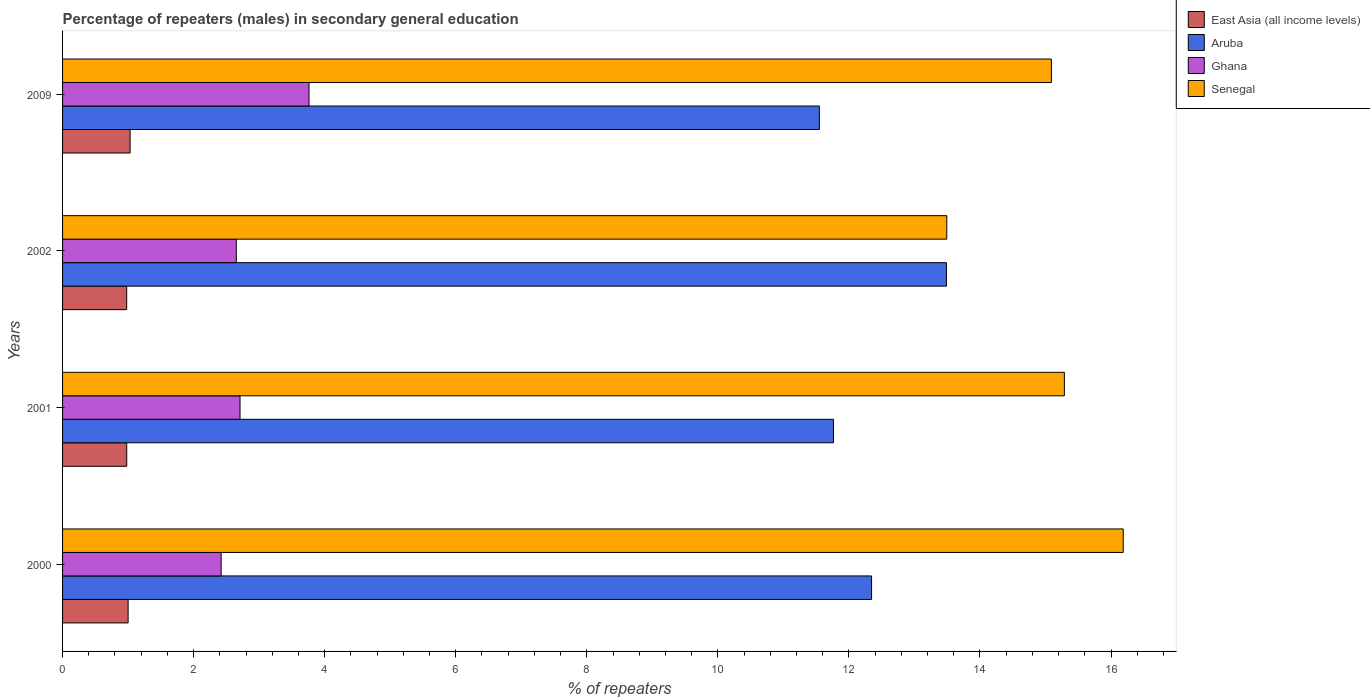How many different coloured bars are there?
Keep it short and to the point. 4. How many bars are there on the 2nd tick from the top?
Your answer should be very brief. 4. How many bars are there on the 1st tick from the bottom?
Your answer should be very brief. 4. What is the label of the 3rd group of bars from the top?
Offer a very short reply. 2001. In how many cases, is the number of bars for a given year not equal to the number of legend labels?
Offer a terse response. 0. What is the percentage of male repeaters in Senegal in 2000?
Keep it short and to the point. 16.19. Across all years, what is the maximum percentage of male repeaters in East Asia (all income levels)?
Your answer should be compact. 1.03. Across all years, what is the minimum percentage of male repeaters in Aruba?
Provide a succinct answer. 11.55. In which year was the percentage of male repeaters in East Asia (all income levels) maximum?
Offer a terse response. 2009. What is the total percentage of male repeaters in Ghana in the graph?
Ensure brevity in your answer.  11.54. What is the difference between the percentage of male repeaters in East Asia (all income levels) in 2001 and that in 2009?
Make the answer very short. -0.05. What is the difference between the percentage of male repeaters in Ghana in 2009 and the percentage of male repeaters in Senegal in 2000?
Make the answer very short. -12.43. What is the average percentage of male repeaters in Aruba per year?
Offer a very short reply. 12.29. In the year 2000, what is the difference between the percentage of male repeaters in East Asia (all income levels) and percentage of male repeaters in Aruba?
Your answer should be very brief. -11.35. In how many years, is the percentage of male repeaters in Senegal greater than 2.8 %?
Offer a terse response. 4. What is the ratio of the percentage of male repeaters in Ghana in 2001 to that in 2002?
Give a very brief answer. 1.02. Is the percentage of male repeaters in Aruba in 2001 less than that in 2002?
Provide a succinct answer. Yes. Is the difference between the percentage of male repeaters in East Asia (all income levels) in 2001 and 2009 greater than the difference between the percentage of male repeaters in Aruba in 2001 and 2009?
Your response must be concise. No. What is the difference between the highest and the second highest percentage of male repeaters in East Asia (all income levels)?
Give a very brief answer. 0.03. What is the difference between the highest and the lowest percentage of male repeaters in Aruba?
Provide a short and direct response. 1.94. Is it the case that in every year, the sum of the percentage of male repeaters in Aruba and percentage of male repeaters in East Asia (all income levels) is greater than the sum of percentage of male repeaters in Senegal and percentage of male repeaters in Ghana?
Provide a short and direct response. No. What does the 3rd bar from the top in 2000 represents?
Offer a very short reply. Aruba. What does the 3rd bar from the bottom in 2009 represents?
Keep it short and to the point. Ghana. How many years are there in the graph?
Keep it short and to the point. 4. Are the values on the major ticks of X-axis written in scientific E-notation?
Keep it short and to the point. No. Does the graph contain grids?
Offer a very short reply. No. How many legend labels are there?
Provide a succinct answer. 4. How are the legend labels stacked?
Provide a succinct answer. Vertical. What is the title of the graph?
Your answer should be compact. Percentage of repeaters (males) in secondary general education. What is the label or title of the X-axis?
Offer a terse response. % of repeaters. What is the label or title of the Y-axis?
Keep it short and to the point. Years. What is the % of repeaters of East Asia (all income levels) in 2000?
Ensure brevity in your answer.  1. What is the % of repeaters of Aruba in 2000?
Provide a short and direct response. 12.35. What is the % of repeaters in Ghana in 2000?
Provide a short and direct response. 2.42. What is the % of repeaters of Senegal in 2000?
Your response must be concise. 16.19. What is the % of repeaters in East Asia (all income levels) in 2001?
Provide a succinct answer. 0.98. What is the % of repeaters in Aruba in 2001?
Keep it short and to the point. 11.76. What is the % of repeaters of Ghana in 2001?
Provide a short and direct response. 2.71. What is the % of repeaters of Senegal in 2001?
Ensure brevity in your answer.  15.29. What is the % of repeaters in East Asia (all income levels) in 2002?
Your response must be concise. 0.98. What is the % of repeaters of Aruba in 2002?
Provide a short and direct response. 13.49. What is the % of repeaters of Ghana in 2002?
Provide a succinct answer. 2.65. What is the % of repeaters in Senegal in 2002?
Keep it short and to the point. 13.49. What is the % of repeaters of East Asia (all income levels) in 2009?
Keep it short and to the point. 1.03. What is the % of repeaters of Aruba in 2009?
Provide a succinct answer. 11.55. What is the % of repeaters of Ghana in 2009?
Offer a terse response. 3.76. What is the % of repeaters in Senegal in 2009?
Provide a short and direct response. 15.09. Across all years, what is the maximum % of repeaters of East Asia (all income levels)?
Your response must be concise. 1.03. Across all years, what is the maximum % of repeaters of Aruba?
Your answer should be compact. 13.49. Across all years, what is the maximum % of repeaters of Ghana?
Offer a very short reply. 3.76. Across all years, what is the maximum % of repeaters of Senegal?
Provide a succinct answer. 16.19. Across all years, what is the minimum % of repeaters in East Asia (all income levels)?
Provide a succinct answer. 0.98. Across all years, what is the minimum % of repeaters in Aruba?
Offer a terse response. 11.55. Across all years, what is the minimum % of repeaters in Ghana?
Keep it short and to the point. 2.42. Across all years, what is the minimum % of repeaters of Senegal?
Provide a succinct answer. 13.49. What is the total % of repeaters of East Asia (all income levels) in the graph?
Offer a terse response. 3.99. What is the total % of repeaters in Aruba in the graph?
Your response must be concise. 49.15. What is the total % of repeaters in Ghana in the graph?
Keep it short and to the point. 11.54. What is the total % of repeaters of Senegal in the graph?
Offer a terse response. 60.06. What is the difference between the % of repeaters of East Asia (all income levels) in 2000 and that in 2001?
Make the answer very short. 0.02. What is the difference between the % of repeaters in Aruba in 2000 and that in 2001?
Give a very brief answer. 0.58. What is the difference between the % of repeaters in Ghana in 2000 and that in 2001?
Your answer should be very brief. -0.29. What is the difference between the % of repeaters of Senegal in 2000 and that in 2001?
Your answer should be very brief. 0.9. What is the difference between the % of repeaters of East Asia (all income levels) in 2000 and that in 2002?
Your answer should be compact. 0.02. What is the difference between the % of repeaters in Aruba in 2000 and that in 2002?
Offer a very short reply. -1.14. What is the difference between the % of repeaters of Ghana in 2000 and that in 2002?
Provide a succinct answer. -0.23. What is the difference between the % of repeaters in Senegal in 2000 and that in 2002?
Provide a succinct answer. 2.69. What is the difference between the % of repeaters in East Asia (all income levels) in 2000 and that in 2009?
Provide a short and direct response. -0.03. What is the difference between the % of repeaters of Aruba in 2000 and that in 2009?
Your answer should be very brief. 0.8. What is the difference between the % of repeaters of Ghana in 2000 and that in 2009?
Your response must be concise. -1.34. What is the difference between the % of repeaters of Senegal in 2000 and that in 2009?
Give a very brief answer. 1.1. What is the difference between the % of repeaters of East Asia (all income levels) in 2001 and that in 2002?
Your response must be concise. 0. What is the difference between the % of repeaters of Aruba in 2001 and that in 2002?
Make the answer very short. -1.72. What is the difference between the % of repeaters in Ghana in 2001 and that in 2002?
Offer a terse response. 0.06. What is the difference between the % of repeaters in Senegal in 2001 and that in 2002?
Ensure brevity in your answer.  1.79. What is the difference between the % of repeaters in East Asia (all income levels) in 2001 and that in 2009?
Make the answer very short. -0.05. What is the difference between the % of repeaters in Aruba in 2001 and that in 2009?
Your answer should be very brief. 0.22. What is the difference between the % of repeaters in Ghana in 2001 and that in 2009?
Make the answer very short. -1.05. What is the difference between the % of repeaters in Senegal in 2001 and that in 2009?
Ensure brevity in your answer.  0.2. What is the difference between the % of repeaters of East Asia (all income levels) in 2002 and that in 2009?
Provide a succinct answer. -0.05. What is the difference between the % of repeaters in Aruba in 2002 and that in 2009?
Offer a very short reply. 1.94. What is the difference between the % of repeaters in Ghana in 2002 and that in 2009?
Your answer should be very brief. -1.11. What is the difference between the % of repeaters in Senegal in 2002 and that in 2009?
Your answer should be compact. -1.6. What is the difference between the % of repeaters in East Asia (all income levels) in 2000 and the % of repeaters in Aruba in 2001?
Your response must be concise. -10.76. What is the difference between the % of repeaters in East Asia (all income levels) in 2000 and the % of repeaters in Ghana in 2001?
Give a very brief answer. -1.71. What is the difference between the % of repeaters in East Asia (all income levels) in 2000 and the % of repeaters in Senegal in 2001?
Offer a terse response. -14.29. What is the difference between the % of repeaters in Aruba in 2000 and the % of repeaters in Ghana in 2001?
Your answer should be compact. 9.64. What is the difference between the % of repeaters in Aruba in 2000 and the % of repeaters in Senegal in 2001?
Offer a very short reply. -2.94. What is the difference between the % of repeaters in Ghana in 2000 and the % of repeaters in Senegal in 2001?
Make the answer very short. -12.87. What is the difference between the % of repeaters of East Asia (all income levels) in 2000 and the % of repeaters of Aruba in 2002?
Keep it short and to the point. -12.49. What is the difference between the % of repeaters of East Asia (all income levels) in 2000 and the % of repeaters of Ghana in 2002?
Provide a short and direct response. -1.65. What is the difference between the % of repeaters of East Asia (all income levels) in 2000 and the % of repeaters of Senegal in 2002?
Ensure brevity in your answer.  -12.49. What is the difference between the % of repeaters in Aruba in 2000 and the % of repeaters in Ghana in 2002?
Give a very brief answer. 9.69. What is the difference between the % of repeaters of Aruba in 2000 and the % of repeaters of Senegal in 2002?
Offer a terse response. -1.15. What is the difference between the % of repeaters of Ghana in 2000 and the % of repeaters of Senegal in 2002?
Offer a very short reply. -11.07. What is the difference between the % of repeaters of East Asia (all income levels) in 2000 and the % of repeaters of Aruba in 2009?
Offer a terse response. -10.55. What is the difference between the % of repeaters of East Asia (all income levels) in 2000 and the % of repeaters of Ghana in 2009?
Provide a short and direct response. -2.76. What is the difference between the % of repeaters of East Asia (all income levels) in 2000 and the % of repeaters of Senegal in 2009?
Your answer should be very brief. -14.09. What is the difference between the % of repeaters of Aruba in 2000 and the % of repeaters of Ghana in 2009?
Make the answer very short. 8.58. What is the difference between the % of repeaters of Aruba in 2000 and the % of repeaters of Senegal in 2009?
Keep it short and to the point. -2.74. What is the difference between the % of repeaters of Ghana in 2000 and the % of repeaters of Senegal in 2009?
Your answer should be compact. -12.67. What is the difference between the % of repeaters in East Asia (all income levels) in 2001 and the % of repeaters in Aruba in 2002?
Provide a short and direct response. -12.51. What is the difference between the % of repeaters of East Asia (all income levels) in 2001 and the % of repeaters of Ghana in 2002?
Keep it short and to the point. -1.67. What is the difference between the % of repeaters in East Asia (all income levels) in 2001 and the % of repeaters in Senegal in 2002?
Offer a terse response. -12.51. What is the difference between the % of repeaters of Aruba in 2001 and the % of repeaters of Ghana in 2002?
Your response must be concise. 9.11. What is the difference between the % of repeaters of Aruba in 2001 and the % of repeaters of Senegal in 2002?
Offer a very short reply. -1.73. What is the difference between the % of repeaters of Ghana in 2001 and the % of repeaters of Senegal in 2002?
Make the answer very short. -10.79. What is the difference between the % of repeaters of East Asia (all income levels) in 2001 and the % of repeaters of Aruba in 2009?
Keep it short and to the point. -10.57. What is the difference between the % of repeaters of East Asia (all income levels) in 2001 and the % of repeaters of Ghana in 2009?
Your answer should be very brief. -2.78. What is the difference between the % of repeaters in East Asia (all income levels) in 2001 and the % of repeaters in Senegal in 2009?
Ensure brevity in your answer.  -14.11. What is the difference between the % of repeaters of Aruba in 2001 and the % of repeaters of Ghana in 2009?
Give a very brief answer. 8. What is the difference between the % of repeaters in Aruba in 2001 and the % of repeaters in Senegal in 2009?
Give a very brief answer. -3.33. What is the difference between the % of repeaters in Ghana in 2001 and the % of repeaters in Senegal in 2009?
Your answer should be compact. -12.38. What is the difference between the % of repeaters of East Asia (all income levels) in 2002 and the % of repeaters of Aruba in 2009?
Ensure brevity in your answer.  -10.57. What is the difference between the % of repeaters in East Asia (all income levels) in 2002 and the % of repeaters in Ghana in 2009?
Ensure brevity in your answer.  -2.78. What is the difference between the % of repeaters of East Asia (all income levels) in 2002 and the % of repeaters of Senegal in 2009?
Make the answer very short. -14.11. What is the difference between the % of repeaters in Aruba in 2002 and the % of repeaters in Ghana in 2009?
Your answer should be very brief. 9.73. What is the difference between the % of repeaters of Aruba in 2002 and the % of repeaters of Senegal in 2009?
Your answer should be compact. -1.6. What is the difference between the % of repeaters in Ghana in 2002 and the % of repeaters in Senegal in 2009?
Your response must be concise. -12.44. What is the average % of repeaters in East Asia (all income levels) per year?
Give a very brief answer. 1. What is the average % of repeaters in Aruba per year?
Offer a terse response. 12.29. What is the average % of repeaters in Ghana per year?
Your response must be concise. 2.89. What is the average % of repeaters of Senegal per year?
Give a very brief answer. 15.01. In the year 2000, what is the difference between the % of repeaters in East Asia (all income levels) and % of repeaters in Aruba?
Ensure brevity in your answer.  -11.35. In the year 2000, what is the difference between the % of repeaters in East Asia (all income levels) and % of repeaters in Ghana?
Offer a terse response. -1.42. In the year 2000, what is the difference between the % of repeaters of East Asia (all income levels) and % of repeaters of Senegal?
Make the answer very short. -15.19. In the year 2000, what is the difference between the % of repeaters of Aruba and % of repeaters of Ghana?
Your answer should be compact. 9.93. In the year 2000, what is the difference between the % of repeaters in Aruba and % of repeaters in Senegal?
Provide a succinct answer. -3.84. In the year 2000, what is the difference between the % of repeaters in Ghana and % of repeaters in Senegal?
Provide a succinct answer. -13.77. In the year 2001, what is the difference between the % of repeaters in East Asia (all income levels) and % of repeaters in Aruba?
Make the answer very short. -10.79. In the year 2001, what is the difference between the % of repeaters in East Asia (all income levels) and % of repeaters in Ghana?
Give a very brief answer. -1.73. In the year 2001, what is the difference between the % of repeaters in East Asia (all income levels) and % of repeaters in Senegal?
Your answer should be compact. -14.31. In the year 2001, what is the difference between the % of repeaters of Aruba and % of repeaters of Ghana?
Provide a succinct answer. 9.06. In the year 2001, what is the difference between the % of repeaters of Aruba and % of repeaters of Senegal?
Provide a short and direct response. -3.52. In the year 2001, what is the difference between the % of repeaters of Ghana and % of repeaters of Senegal?
Provide a succinct answer. -12.58. In the year 2002, what is the difference between the % of repeaters in East Asia (all income levels) and % of repeaters in Aruba?
Provide a short and direct response. -12.51. In the year 2002, what is the difference between the % of repeaters in East Asia (all income levels) and % of repeaters in Ghana?
Give a very brief answer. -1.67. In the year 2002, what is the difference between the % of repeaters of East Asia (all income levels) and % of repeaters of Senegal?
Ensure brevity in your answer.  -12.52. In the year 2002, what is the difference between the % of repeaters of Aruba and % of repeaters of Ghana?
Provide a succinct answer. 10.84. In the year 2002, what is the difference between the % of repeaters in Aruba and % of repeaters in Senegal?
Provide a short and direct response. -0. In the year 2002, what is the difference between the % of repeaters in Ghana and % of repeaters in Senegal?
Ensure brevity in your answer.  -10.84. In the year 2009, what is the difference between the % of repeaters of East Asia (all income levels) and % of repeaters of Aruba?
Your response must be concise. -10.52. In the year 2009, what is the difference between the % of repeaters of East Asia (all income levels) and % of repeaters of Ghana?
Offer a very short reply. -2.73. In the year 2009, what is the difference between the % of repeaters of East Asia (all income levels) and % of repeaters of Senegal?
Your answer should be compact. -14.06. In the year 2009, what is the difference between the % of repeaters of Aruba and % of repeaters of Ghana?
Make the answer very short. 7.79. In the year 2009, what is the difference between the % of repeaters in Aruba and % of repeaters in Senegal?
Your answer should be compact. -3.54. In the year 2009, what is the difference between the % of repeaters in Ghana and % of repeaters in Senegal?
Make the answer very short. -11.33. What is the ratio of the % of repeaters in East Asia (all income levels) in 2000 to that in 2001?
Offer a very short reply. 1.02. What is the ratio of the % of repeaters of Aruba in 2000 to that in 2001?
Your answer should be compact. 1.05. What is the ratio of the % of repeaters in Ghana in 2000 to that in 2001?
Your response must be concise. 0.89. What is the ratio of the % of repeaters in Senegal in 2000 to that in 2001?
Your answer should be compact. 1.06. What is the ratio of the % of repeaters of East Asia (all income levels) in 2000 to that in 2002?
Offer a very short reply. 1.02. What is the ratio of the % of repeaters in Aruba in 2000 to that in 2002?
Your answer should be very brief. 0.92. What is the ratio of the % of repeaters of Ghana in 2000 to that in 2002?
Give a very brief answer. 0.91. What is the ratio of the % of repeaters of Senegal in 2000 to that in 2002?
Offer a very short reply. 1.2. What is the ratio of the % of repeaters in East Asia (all income levels) in 2000 to that in 2009?
Provide a short and direct response. 0.97. What is the ratio of the % of repeaters in Aruba in 2000 to that in 2009?
Ensure brevity in your answer.  1.07. What is the ratio of the % of repeaters in Ghana in 2000 to that in 2009?
Provide a succinct answer. 0.64. What is the ratio of the % of repeaters in Senegal in 2000 to that in 2009?
Provide a short and direct response. 1.07. What is the ratio of the % of repeaters in Aruba in 2001 to that in 2002?
Offer a terse response. 0.87. What is the ratio of the % of repeaters in Ghana in 2001 to that in 2002?
Provide a succinct answer. 1.02. What is the ratio of the % of repeaters in Senegal in 2001 to that in 2002?
Your answer should be very brief. 1.13. What is the ratio of the % of repeaters in Aruba in 2001 to that in 2009?
Offer a terse response. 1.02. What is the ratio of the % of repeaters of Ghana in 2001 to that in 2009?
Offer a terse response. 0.72. What is the ratio of the % of repeaters in Senegal in 2001 to that in 2009?
Provide a succinct answer. 1.01. What is the ratio of the % of repeaters in East Asia (all income levels) in 2002 to that in 2009?
Your response must be concise. 0.95. What is the ratio of the % of repeaters of Aruba in 2002 to that in 2009?
Your response must be concise. 1.17. What is the ratio of the % of repeaters of Ghana in 2002 to that in 2009?
Your answer should be very brief. 0.7. What is the ratio of the % of repeaters in Senegal in 2002 to that in 2009?
Offer a very short reply. 0.89. What is the difference between the highest and the second highest % of repeaters of East Asia (all income levels)?
Provide a succinct answer. 0.03. What is the difference between the highest and the second highest % of repeaters in Aruba?
Make the answer very short. 1.14. What is the difference between the highest and the second highest % of repeaters in Ghana?
Your response must be concise. 1.05. What is the difference between the highest and the second highest % of repeaters of Senegal?
Offer a very short reply. 0.9. What is the difference between the highest and the lowest % of repeaters of East Asia (all income levels)?
Your answer should be very brief. 0.05. What is the difference between the highest and the lowest % of repeaters of Aruba?
Offer a terse response. 1.94. What is the difference between the highest and the lowest % of repeaters of Ghana?
Your answer should be very brief. 1.34. What is the difference between the highest and the lowest % of repeaters of Senegal?
Your response must be concise. 2.69. 